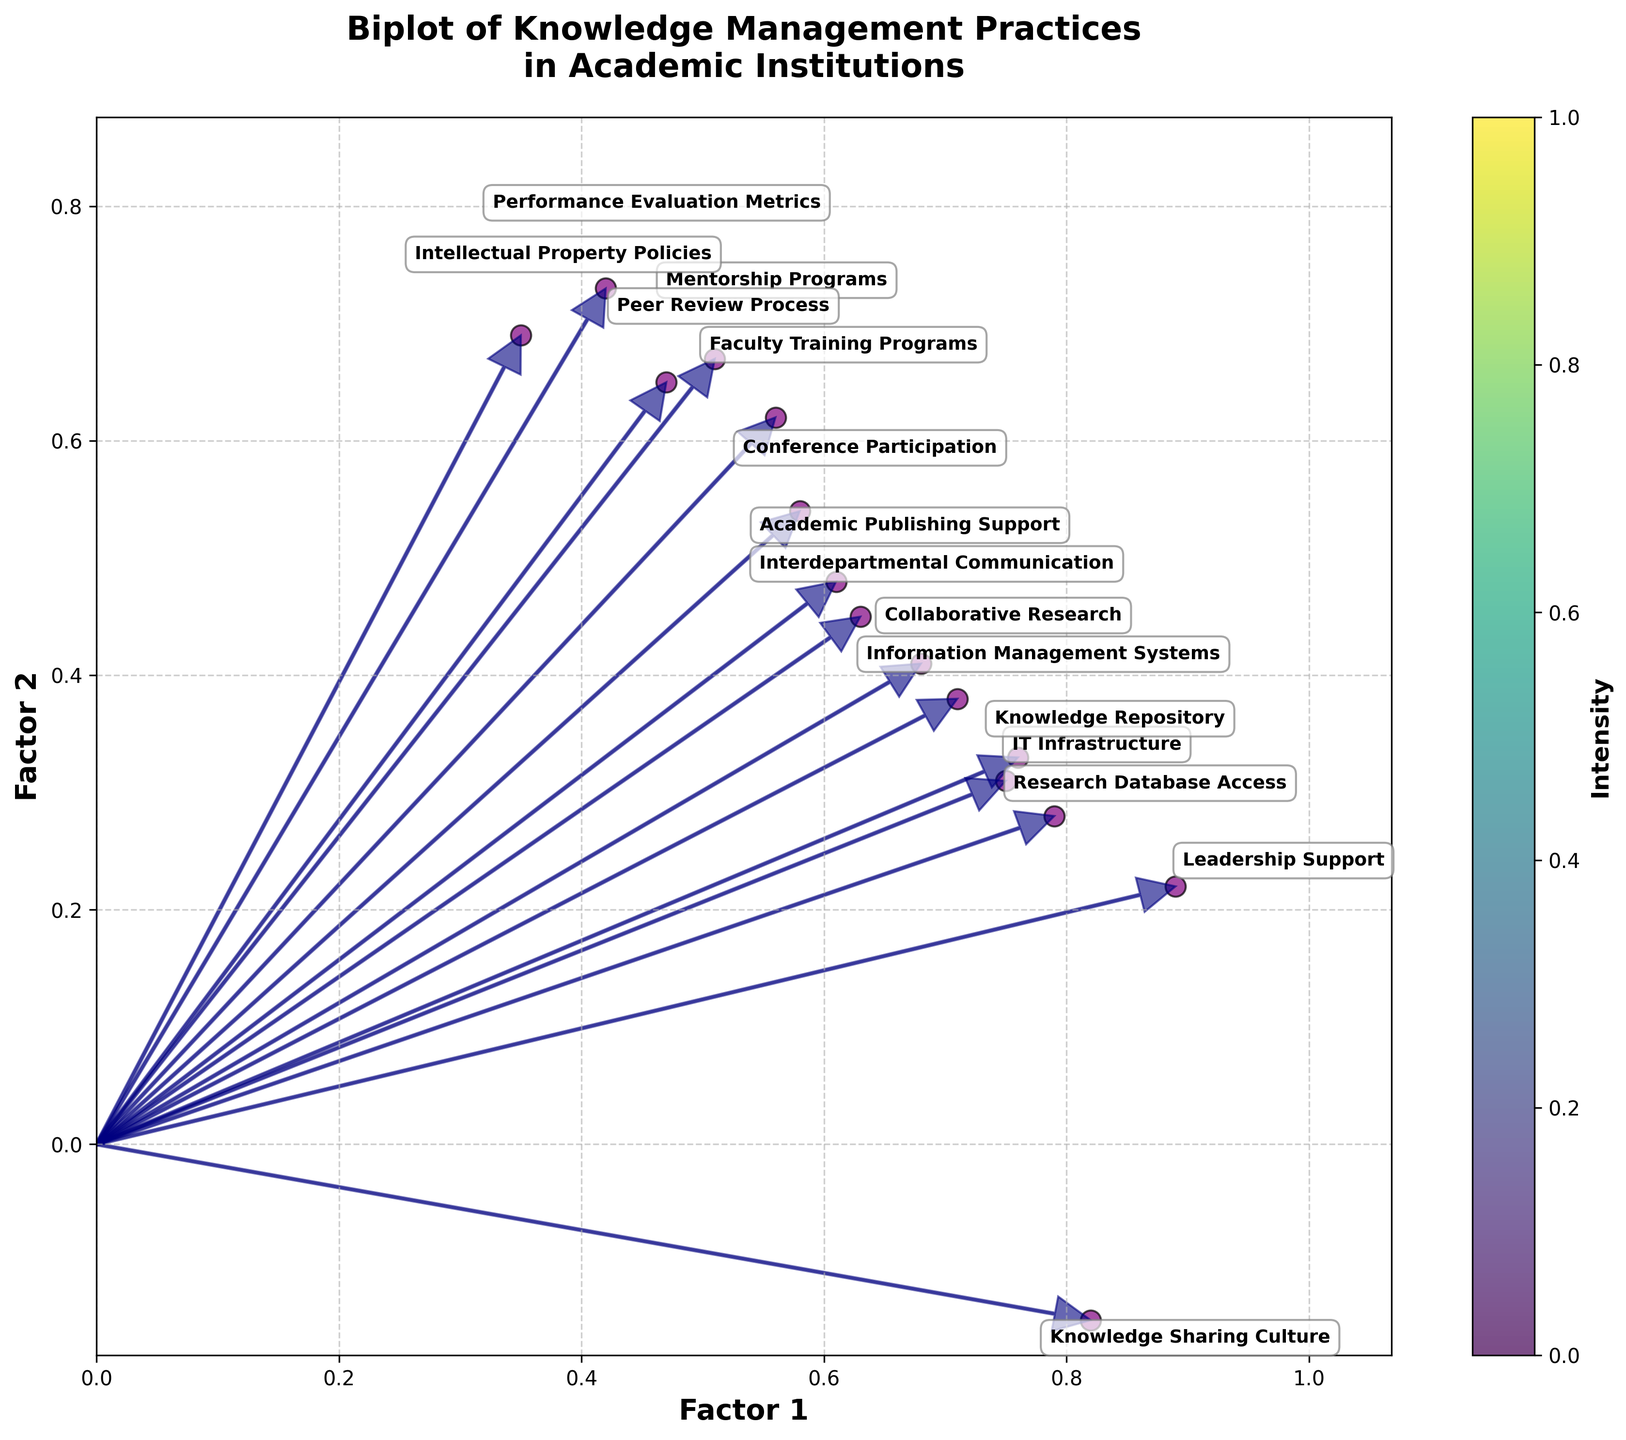What is the title of the biplot? The title of the biplot is displayed at the top of the figure. It reads: "Biplot of Knowledge Management Practices in Academic Institutions".
Answer: Biplot of Knowledge Management Practices in Academic Institutions Which factor has the highest value for "Leadership Support"? "Leadership Support" has the highest value on Factor 1, and lower on Factor 2 when compared to Factor 1. Factor 1 has a value of 0.89 for "Leadership Support".
Answer: Factor 1 How many variables have a Factor 2 component greater than 0.5? To identify this, we look for all variables where the Factor 2 value is greater than 0.5. These variables are Faculty Training Programs, Mentorship Programs, Performance Evaluation Metrics, Intellectual Property Policies, Peer Review Process, and Academic Publishing Support which totals to six.
Answer: 6 Which variable is closest to the origin (0, 0) on the plot? To determine the variable closest to the origin, we compare the proximity of each point to the origin using a distance measure. "Intellectual Property Policies" (0.35, 0.69) seems closest to the origin, as its factor values are the smallest in magnitude.
Answer: Intellectual Property Policies Which variables are more associated with Factor 2 than Factor 1? We look for variables where the absolute value on Factor 2 is greater than the absolute value on Factor 1. These variables include Faculty Training Programs, Mentorship Programs, Performance Evaluation Metrics, Intellectual Property Policies, Conference Participation, Peer Review Process, and Academic Publishing Support.
Answer: Faculty Training Programs, Mentorship Programs, Performance Evaluation Metrics, Intellectual Property Policies, Conference Participation, Peer Review Process, Academic Publishing Support What is the average value of Factor 2 for the variables "Research Database Access", "Knowledge Sharing Culture", and "Leadership Support"? We sum the Factor 2 values for the mentioned variables and divide by the number of variables. Factor 2 values are: Research Database Access (0.28), Knowledge Sharing Culture (-0.15), Leadership Support (0.22). The sum of these values is 0.35. The average is then 0.35/3 = 0.1167.
Answer: 0.1167 Which variables show a positive component in both Factor 1 and Factor 2? We identify variables where both Factor 1 and Factor 2 values are positive. These variables are IT Infrastructure, Leadership Support, Collaborative Research, Information Management Systems, Research Database Access, Knowledge Repository, and Academic Publishing Support.
Answer: IT Infrastructure, Leadership Support, Collaborative Research, Information Management Systems, Research Database Access, Knowledge Repository, Academic Publishing Support What is the vector direction (orientation) of "Conference Participation"? To determine vector direction, we observe the sign and relative magnitude of Factor 1 and Factor 2 for "Conference Participation". Both Factor 1 (0.58) and Factor 2 (0.54) are positive, indicating it's oriented in the first quadrant, slanting slightly upwards to the right.
Answer: First quadrant, slanting upwards to the right 